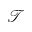<formula> <loc_0><loc_0><loc_500><loc_500>\mathcal { T }</formula> 